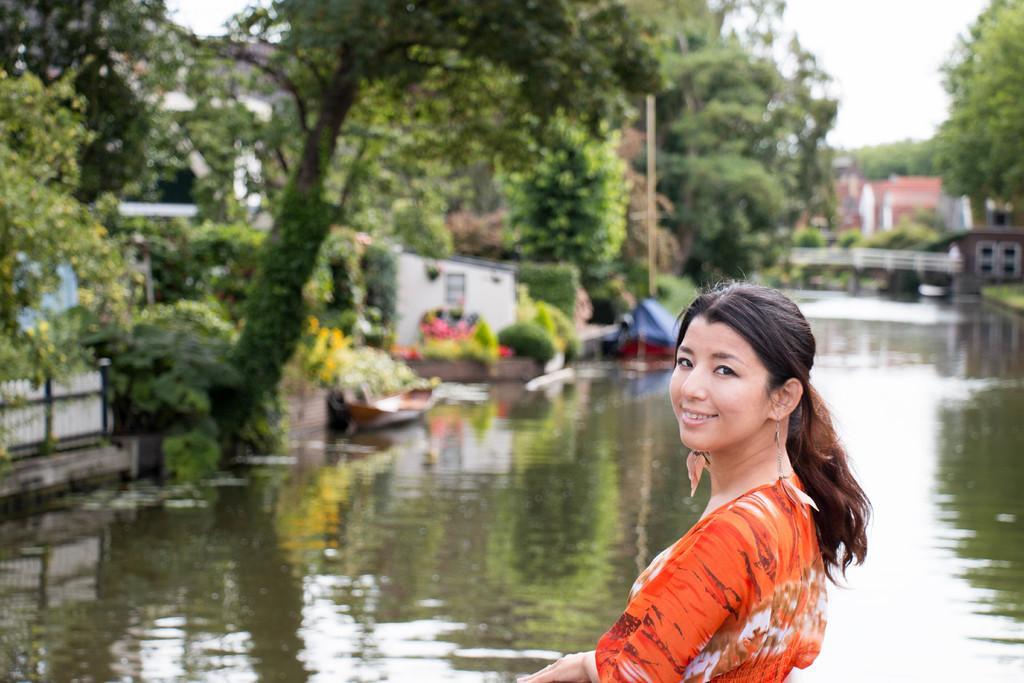In one or two sentences, can you explain what this image depicts? In this image I can see the person is wearing orange and white color dress. I can see few trees, buildings, water and few objects and it is blurred. 